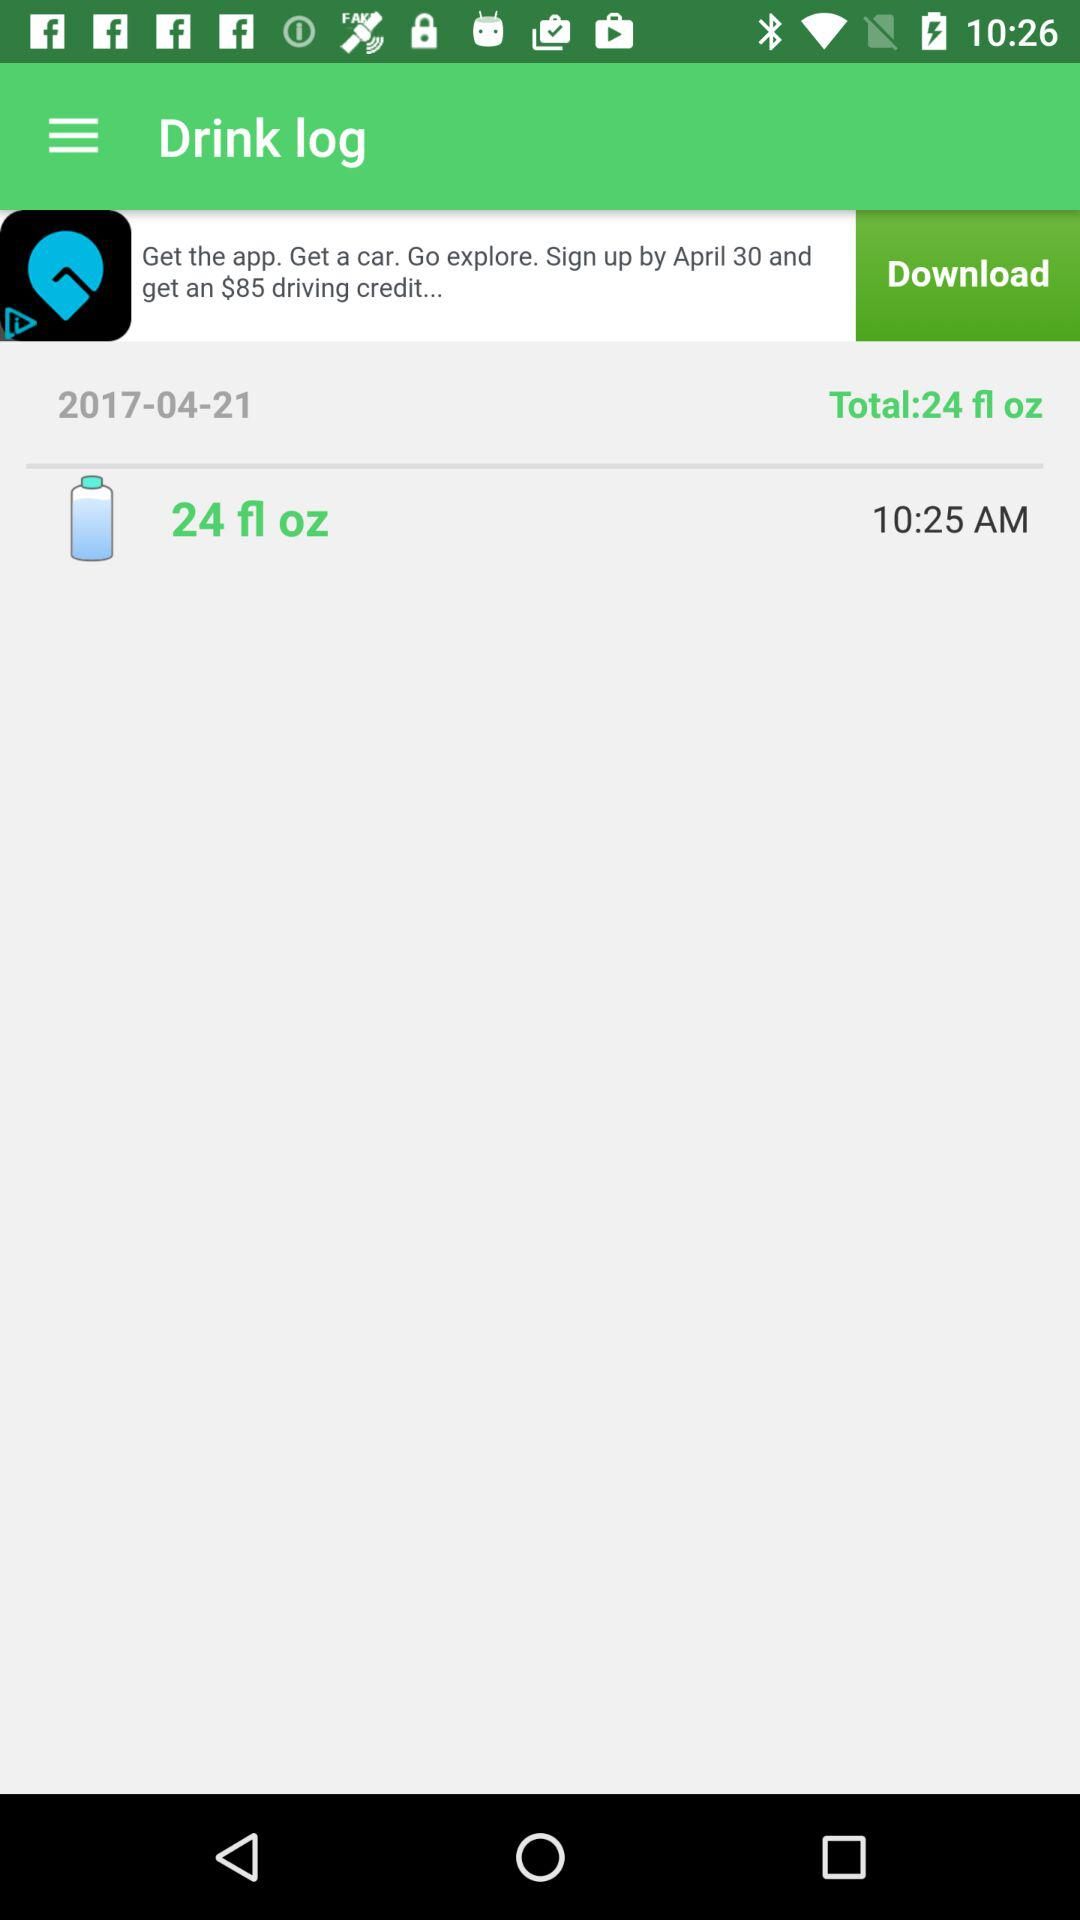What time did I drink the last water?
Answer the question using a single word or phrase. 10:25 AM 